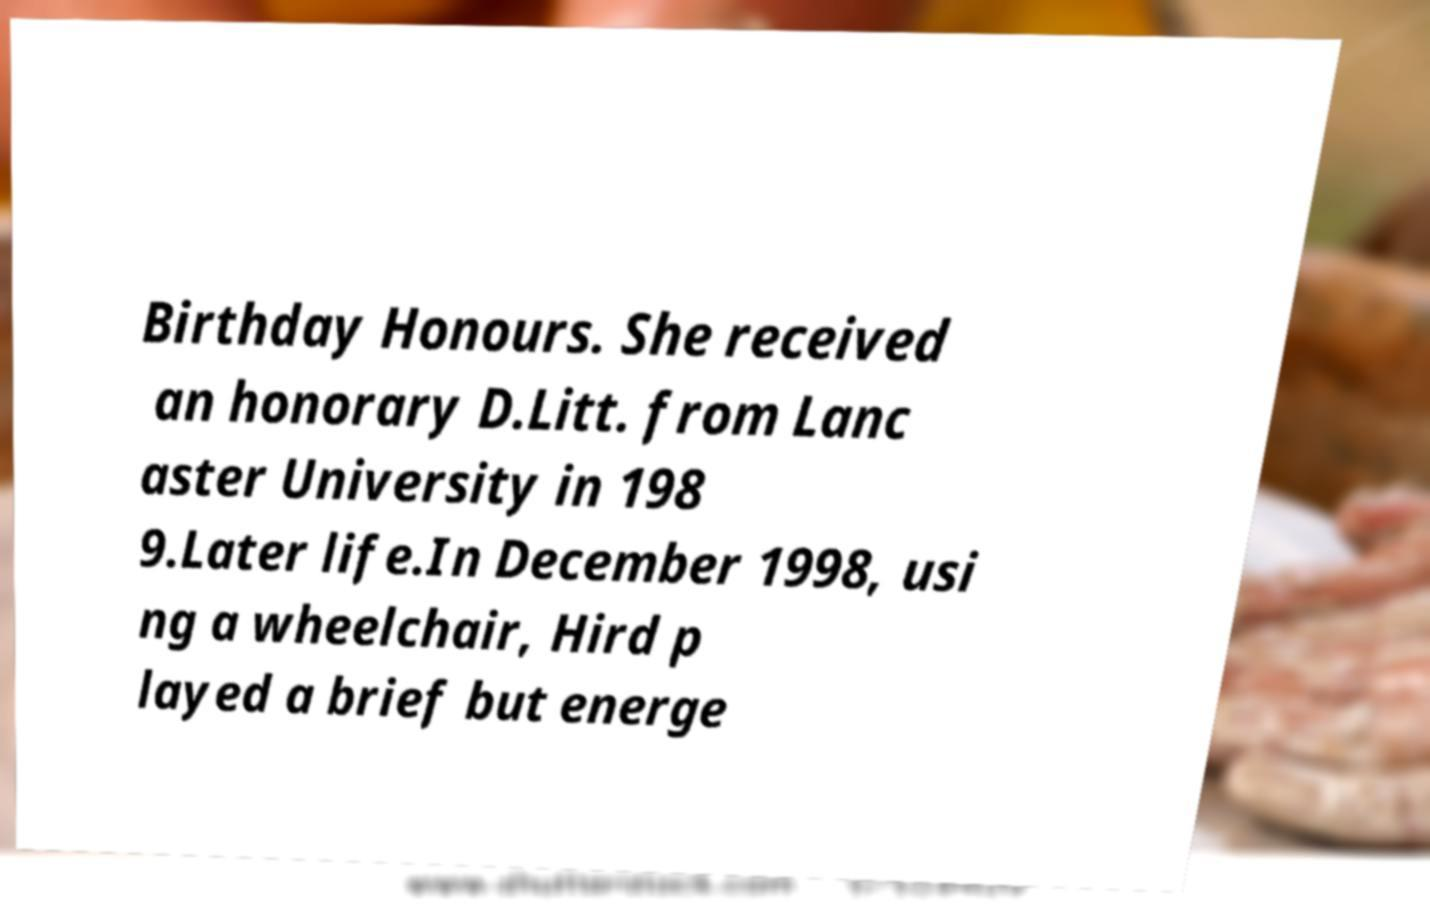Can you accurately transcribe the text from the provided image for me? Birthday Honours. She received an honorary D.Litt. from Lanc aster University in 198 9.Later life.In December 1998, usi ng a wheelchair, Hird p layed a brief but energe 